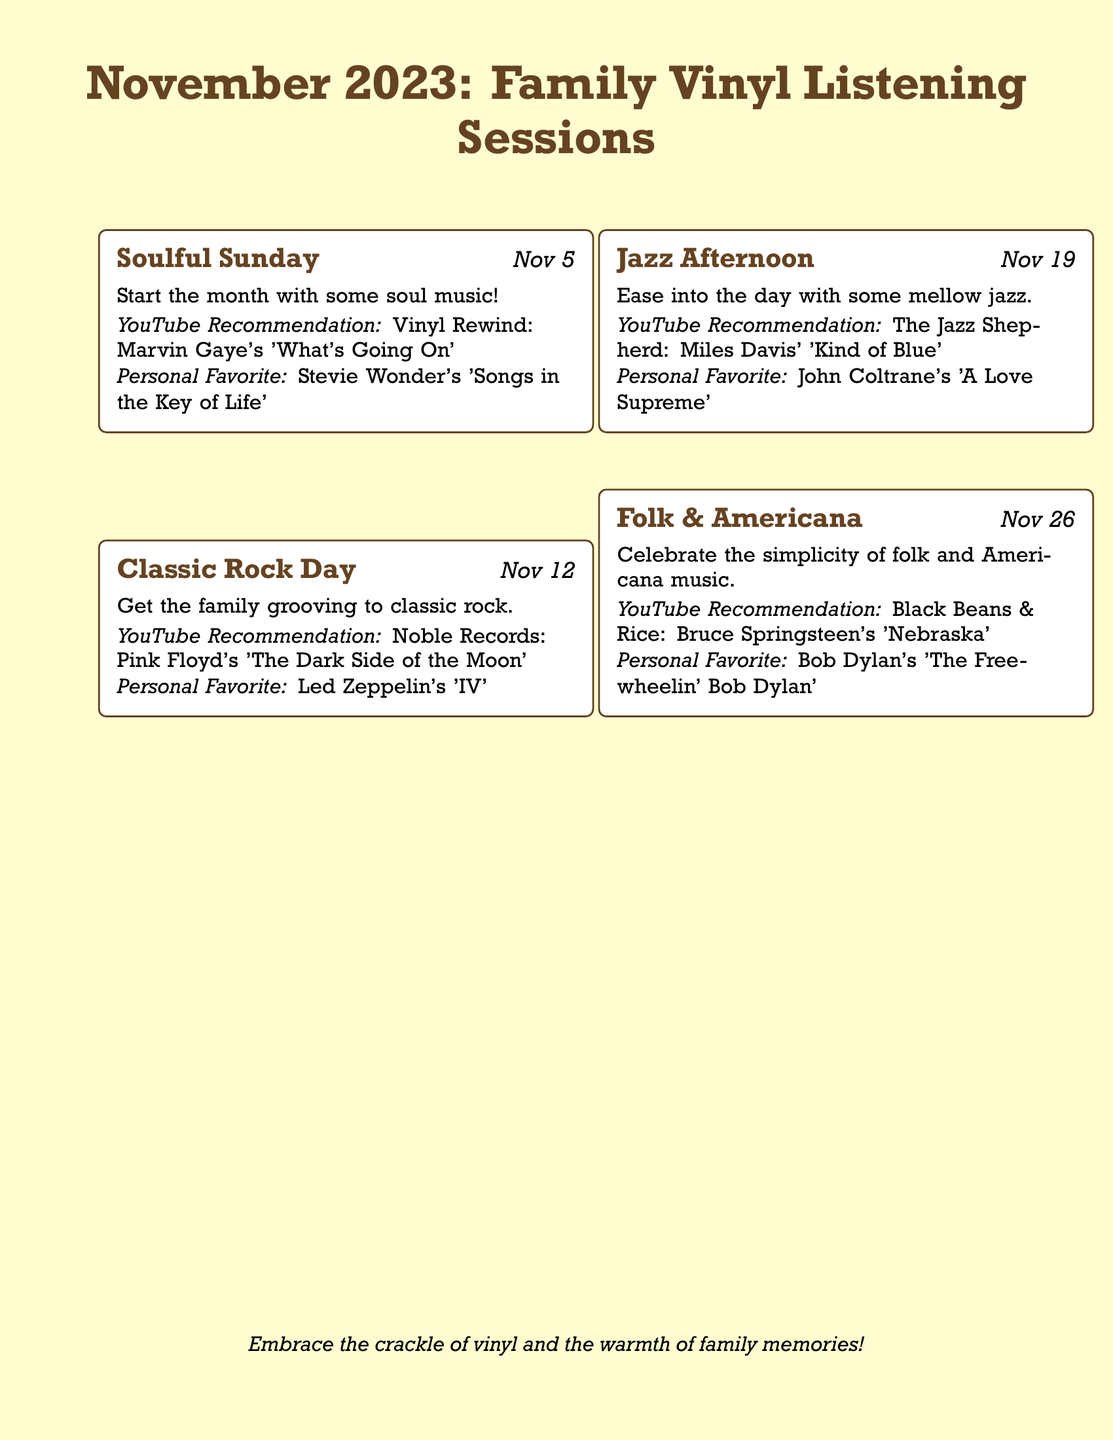What is the theme for November 5? The theme for this date is the first scheduled event in the calendar which is specifically titled "Soulful Sunday."
Answer: Soulful Sunday What album is recommended for November 12? The document states that the YouTube recommendation for this event is Pink Floyd's 'The Dark Side of the Moon.'
Answer: Pink Floyd's 'The Dark Side of the Moon' How many Vinyl Listening Sessions are listed for November 2023? The document details four specific sessions for the month of November 2023.
Answer: Four What is the personal favorite album for Jazz Afternoon? The personal favorite listed for this session is John Coltrane's 'A Love Supreme.'
Answer: John Coltrane's 'A Love Supreme' Which artist's work is featured on November 26 under Folk & Americana? The document mentions Bruce Springsteen's 'Nebraska' as part of the YouTube recommendation for this date.
Answer: Bruce Springsteen Which session occurs on November 19? Referring to the calendar, the session that takes place on this date is titled "Jazz Afternoon."
Answer: Jazz Afternoon How are the vinyl listening sessions visually distinguished in this document? The document uses event boxes to visually present and separate each vinyl listening session with specific information.
Answer: Event boxes What is included at the bottom of the document? The document concludes with a small italicized note encouraging the embrace of vinyl and family memories.
Answer: A note about vinyl and family memories 